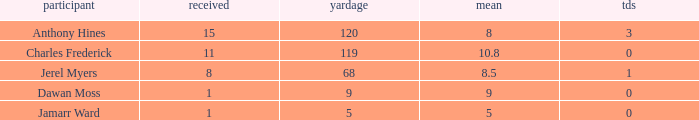What is the total Avg when TDs are 0 and Dawan Moss is a player? 0.0. 